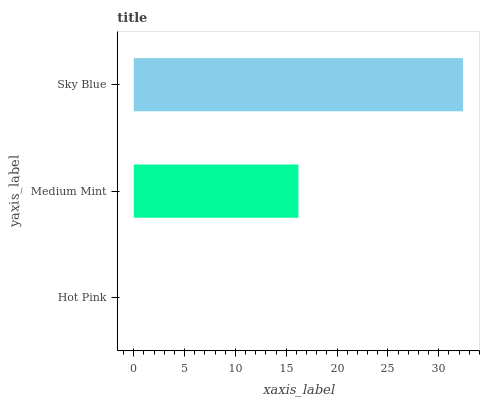Is Hot Pink the minimum?
Answer yes or no. Yes. Is Sky Blue the maximum?
Answer yes or no. Yes. Is Medium Mint the minimum?
Answer yes or no. No. Is Medium Mint the maximum?
Answer yes or no. No. Is Medium Mint greater than Hot Pink?
Answer yes or no. Yes. Is Hot Pink less than Medium Mint?
Answer yes or no. Yes. Is Hot Pink greater than Medium Mint?
Answer yes or no. No. Is Medium Mint less than Hot Pink?
Answer yes or no. No. Is Medium Mint the high median?
Answer yes or no. Yes. Is Medium Mint the low median?
Answer yes or no. Yes. Is Sky Blue the high median?
Answer yes or no. No. Is Hot Pink the low median?
Answer yes or no. No. 